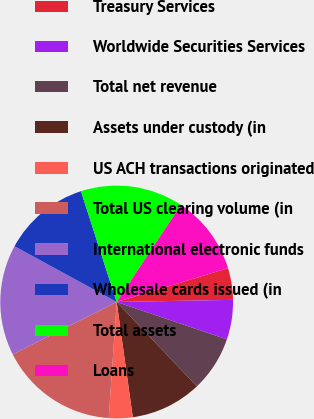Convert chart to OTSL. <chart><loc_0><loc_0><loc_500><loc_500><pie_chart><fcel>Treasury Services<fcel>Worldwide Securities Services<fcel>Total net revenue<fcel>Assets under custody (in<fcel>US ACH transactions originated<fcel>Total US clearing volume (in<fcel>International electronic funds<fcel>Wholesale cards issued (in<fcel>Total assets<fcel>Loans<nl><fcel>4.4%<fcel>5.5%<fcel>7.69%<fcel>9.89%<fcel>3.3%<fcel>16.48%<fcel>15.38%<fcel>12.09%<fcel>14.28%<fcel>10.99%<nl></chart> 